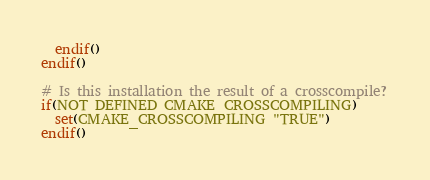Convert code to text. <code><loc_0><loc_0><loc_500><loc_500><_CMake_>  endif()
endif()

# Is this installation the result of a crosscompile?
if(NOT DEFINED CMAKE_CROSSCOMPILING)
  set(CMAKE_CROSSCOMPILING "TRUE")
endif()

</code> 